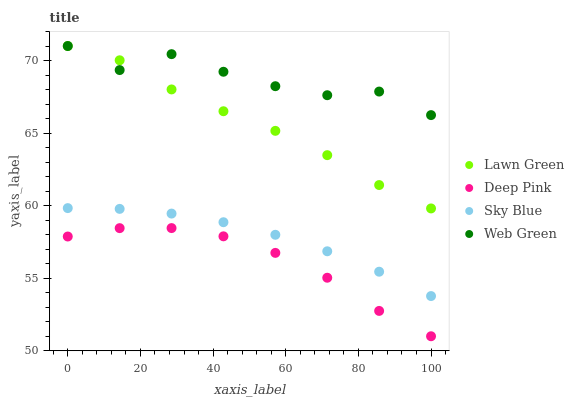Does Deep Pink have the minimum area under the curve?
Answer yes or no. Yes. Does Web Green have the maximum area under the curve?
Answer yes or no. Yes. Does Web Green have the minimum area under the curve?
Answer yes or no. No. Does Deep Pink have the maximum area under the curve?
Answer yes or no. No. Is Sky Blue the smoothest?
Answer yes or no. Yes. Is Web Green the roughest?
Answer yes or no. Yes. Is Deep Pink the smoothest?
Answer yes or no. No. Is Deep Pink the roughest?
Answer yes or no. No. Does Deep Pink have the lowest value?
Answer yes or no. Yes. Does Web Green have the lowest value?
Answer yes or no. No. Does Web Green have the highest value?
Answer yes or no. Yes. Does Deep Pink have the highest value?
Answer yes or no. No. Is Sky Blue less than Lawn Green?
Answer yes or no. Yes. Is Lawn Green greater than Deep Pink?
Answer yes or no. Yes. Does Web Green intersect Lawn Green?
Answer yes or no. Yes. Is Web Green less than Lawn Green?
Answer yes or no. No. Is Web Green greater than Lawn Green?
Answer yes or no. No. Does Sky Blue intersect Lawn Green?
Answer yes or no. No. 